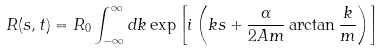Convert formula to latex. <formula><loc_0><loc_0><loc_500><loc_500>R ( s , t ) = R _ { 0 } \int _ { - \infty } ^ { \infty } d k \exp \left [ i \left ( k s + \frac { \alpha } { 2 A m } \arctan \frac { k } { m } \right ) \right ]</formula> 